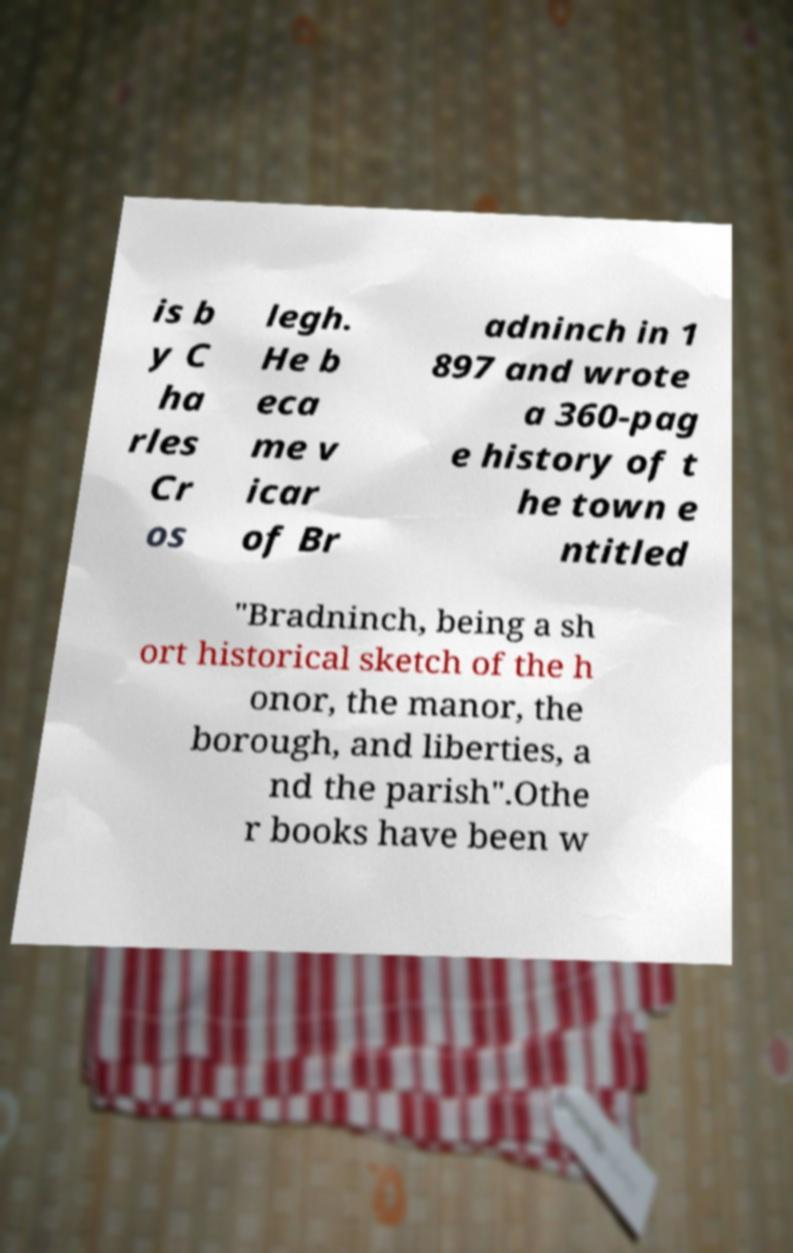There's text embedded in this image that I need extracted. Can you transcribe it verbatim? is b y C ha rles Cr os legh. He b eca me v icar of Br adninch in 1 897 and wrote a 360-pag e history of t he town e ntitled "Bradninch, being a sh ort historical sketch of the h onor, the manor, the borough, and liberties, a nd the parish".Othe r books have been w 